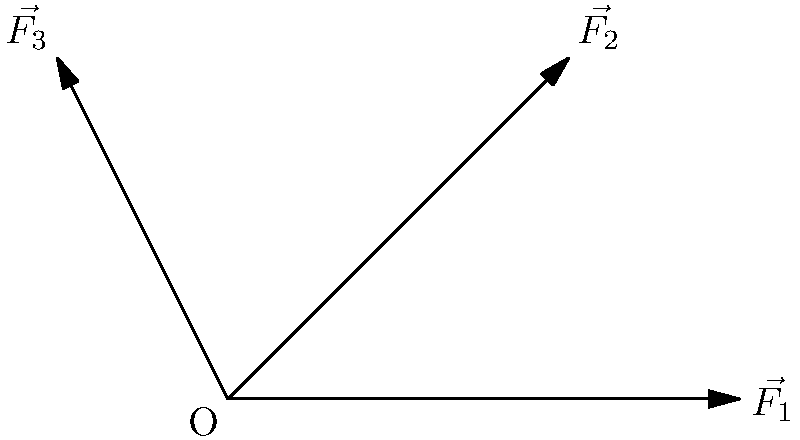In a study of drug interactions, three medications are represented by force vectors $\vec{F_1}$, $\vec{F_2}$, and $\vec{F_3}$ as shown in the diagram. $\vec{F_1}$ has a magnitude of 3 units and acts along the positive x-axis, $\vec{F_2}$ has a magnitude of $2\sqrt{2}$ units and acts at 45° to the positive x-axis, and $\vec{F_3}$ has a magnitude of $\sqrt{5}$ units and acts at 120° to the positive x-axis. Calculate the magnitude of the resultant force vector representing the combined effect of these drug interactions. To find the magnitude of the resultant force vector, we need to follow these steps:

1) First, let's break down each vector into its x and y components:

   $\vec{F_1}$: $F_{1x} = 3$, $F_{1y} = 0$
   $\vec{F_2}$: $F_{2x} = 2\sqrt{2} \cos 45° = 2$, $F_{2y} = 2\sqrt{2} \sin 45° = 2$
   $\vec{F_3}$: $F_{3x} = \sqrt{5} \cos 120° = -\frac{\sqrt{5}}{2}$, $F_{3y} = \sqrt{5} \sin 120° = \frac{\sqrt{15}}{2}$

2) Now, we sum up all the x-components and y-components separately:

   $F_x = F_{1x} + F_{2x} + F_{3x} = 3 + 2 - \frac{\sqrt{5}}{2} = 5 - \frac{\sqrt{5}}{2}$
   $F_y = F_{1y} + F_{2y} + F_{3y} = 0 + 2 + \frac{\sqrt{15}}{2} = 2 + \frac{\sqrt{15}}{2}$

3) The magnitude of the resultant force vector is given by the Pythagorean theorem:

   $|\vec{F}_{resultant}| = \sqrt{F_x^2 + F_y^2}$

4) Substituting the values:

   $|\vec{F}_{resultant}| = \sqrt{(5 - \frac{\sqrt{5}}{2})^2 + (2 + \frac{\sqrt{15}}{2})^2}$

5) Simplifying under the square root:

   $|\vec{F}_{resultant}| = \sqrt{25 - 5\sqrt{5} + \frac{5}{4} + 4 + 2\sqrt{15} + \frac{15}{4}}$
   $= \sqrt{30 - 5\sqrt{5} + 2\sqrt{15}}$

This is the magnitude of the resultant force vector.
Answer: $\sqrt{30 - 5\sqrt{5} + 2\sqrt{15}}$ units 